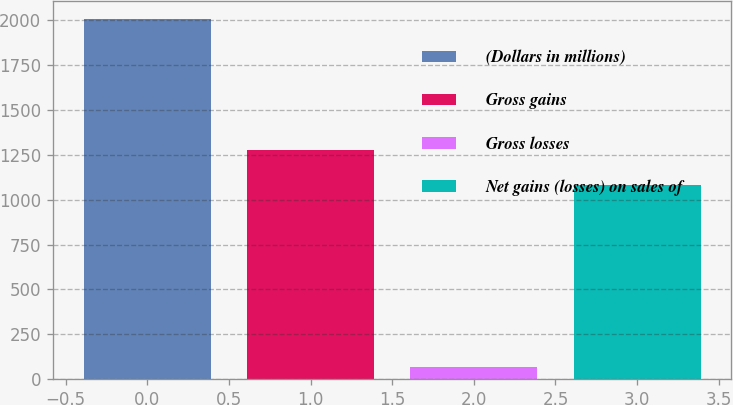Convert chart. <chart><loc_0><loc_0><loc_500><loc_500><bar_chart><fcel>(Dollars in millions)<fcel>Gross gains<fcel>Gross losses<fcel>Net gains (losses) on sales of<nl><fcel>2005<fcel>1277.5<fcel>70<fcel>1084<nl></chart> 